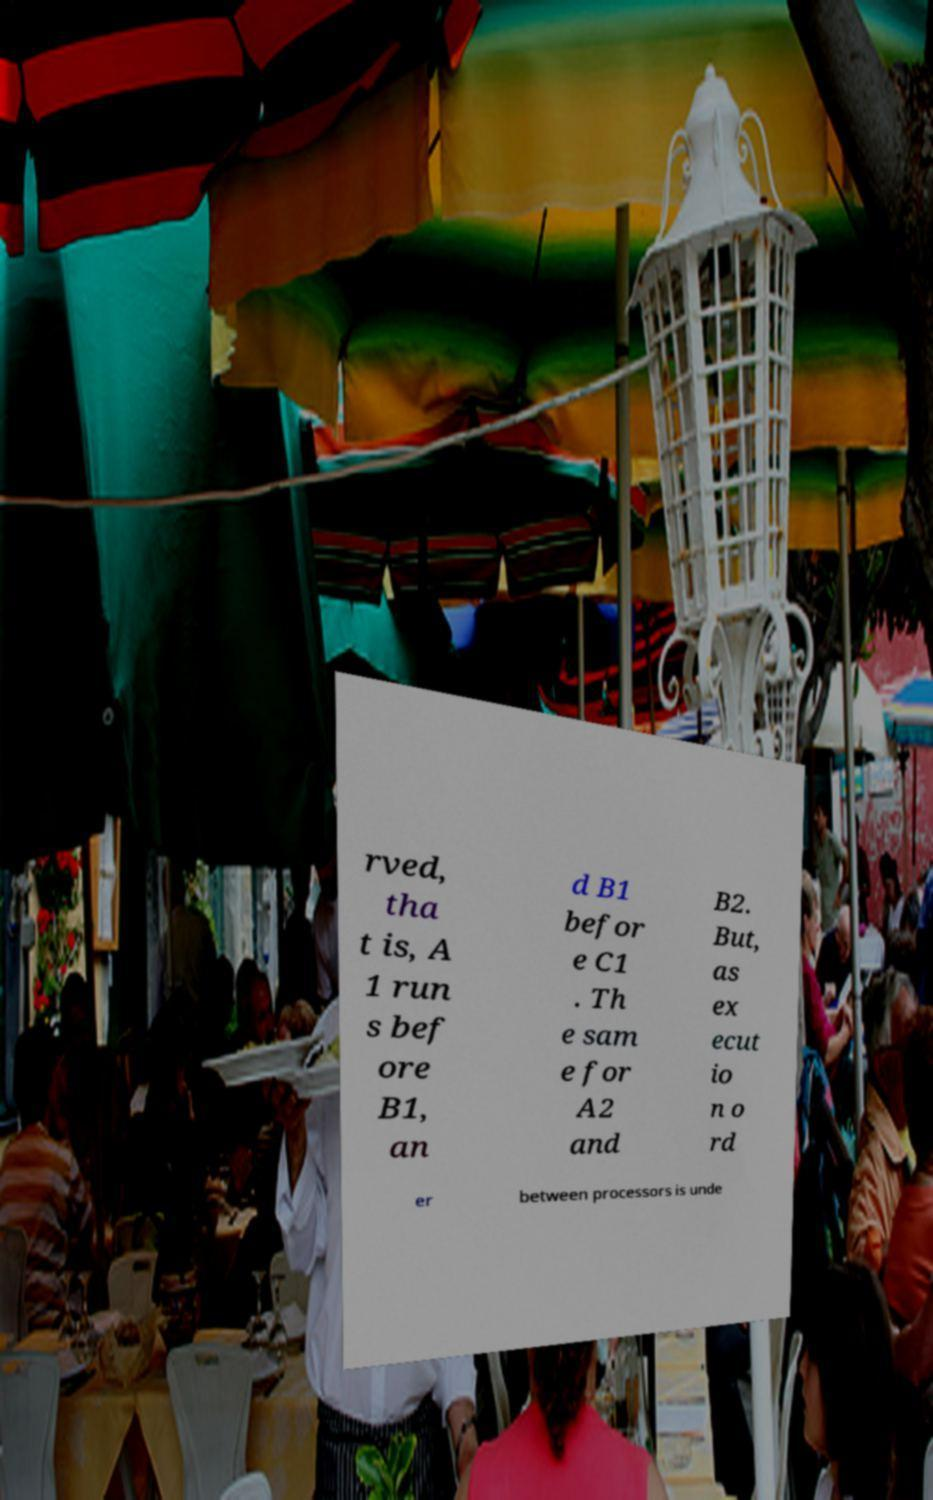I need the written content from this picture converted into text. Can you do that? rved, tha t is, A 1 run s bef ore B1, an d B1 befor e C1 . Th e sam e for A2 and B2. But, as ex ecut io n o rd er between processors is unde 